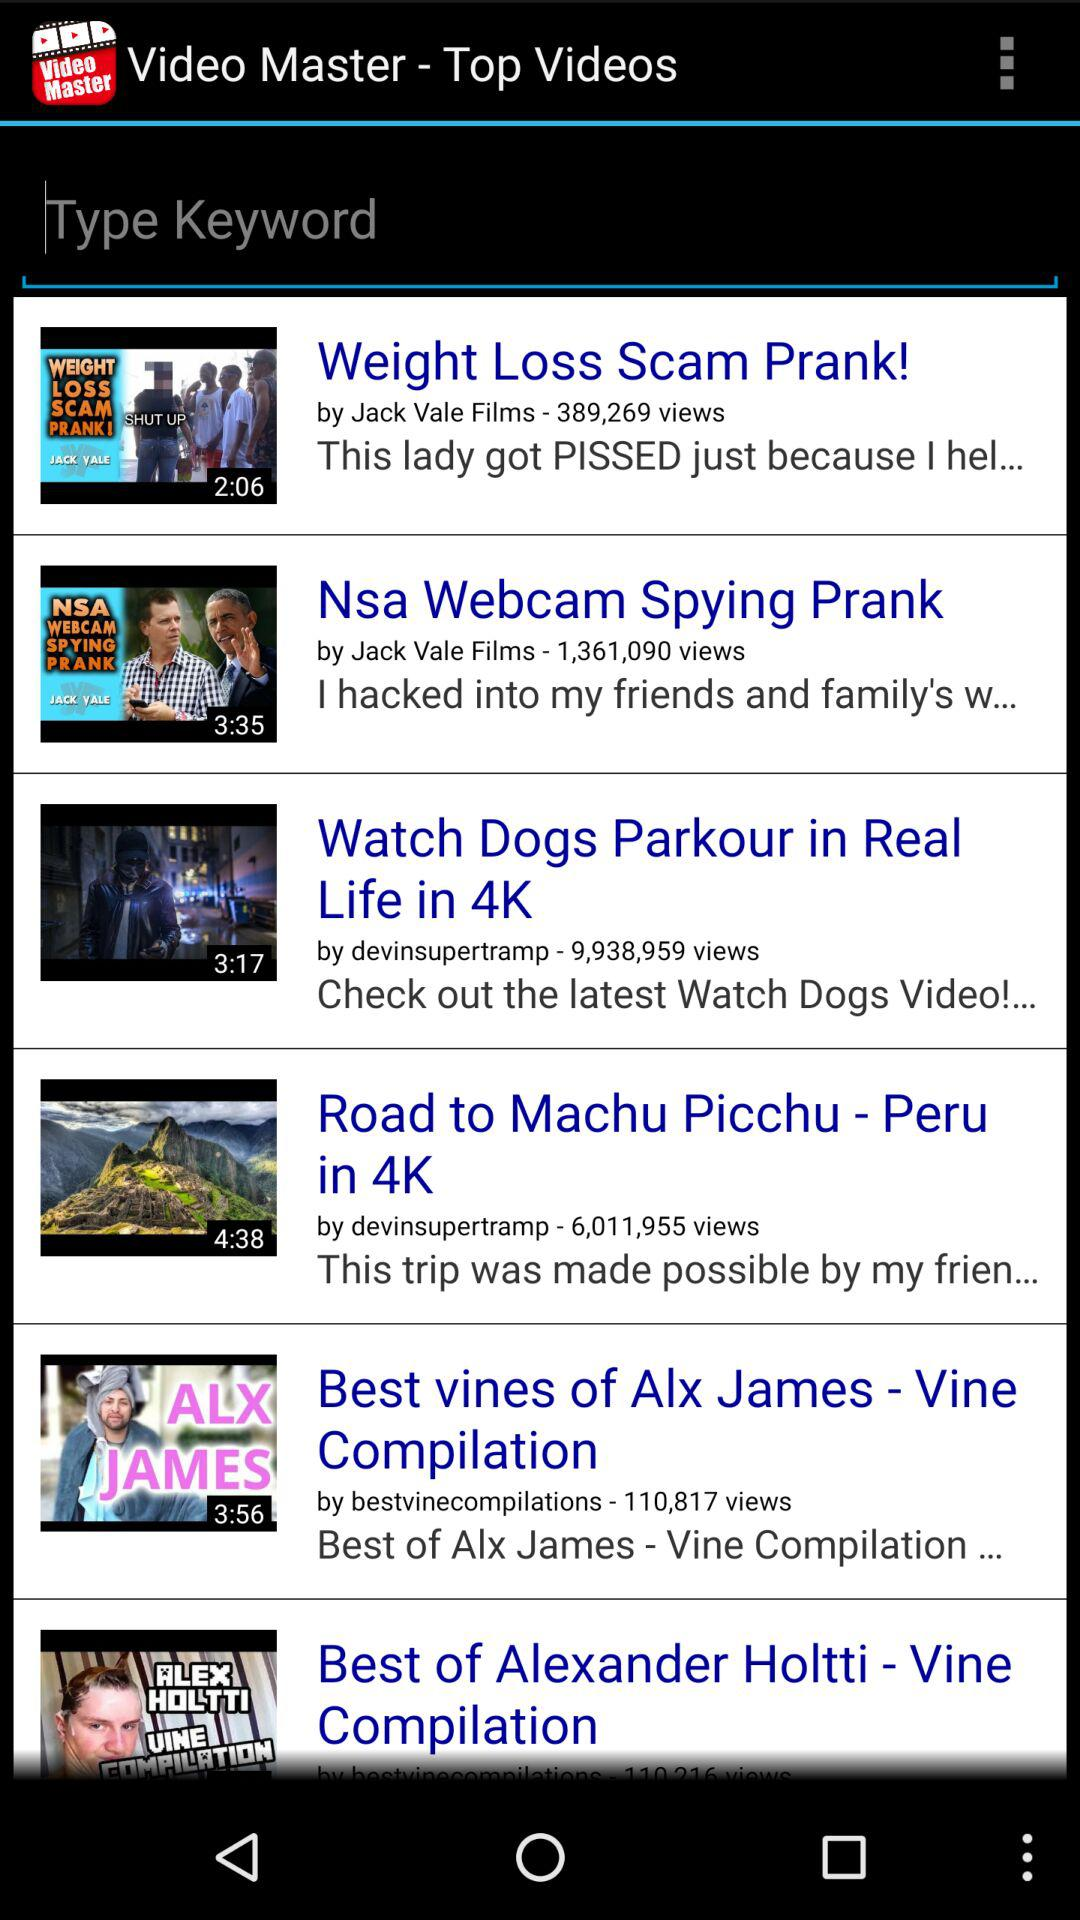Who has posted the "Nsa Webcam Spying Prank"? It is posted by Jack Vale Films. 